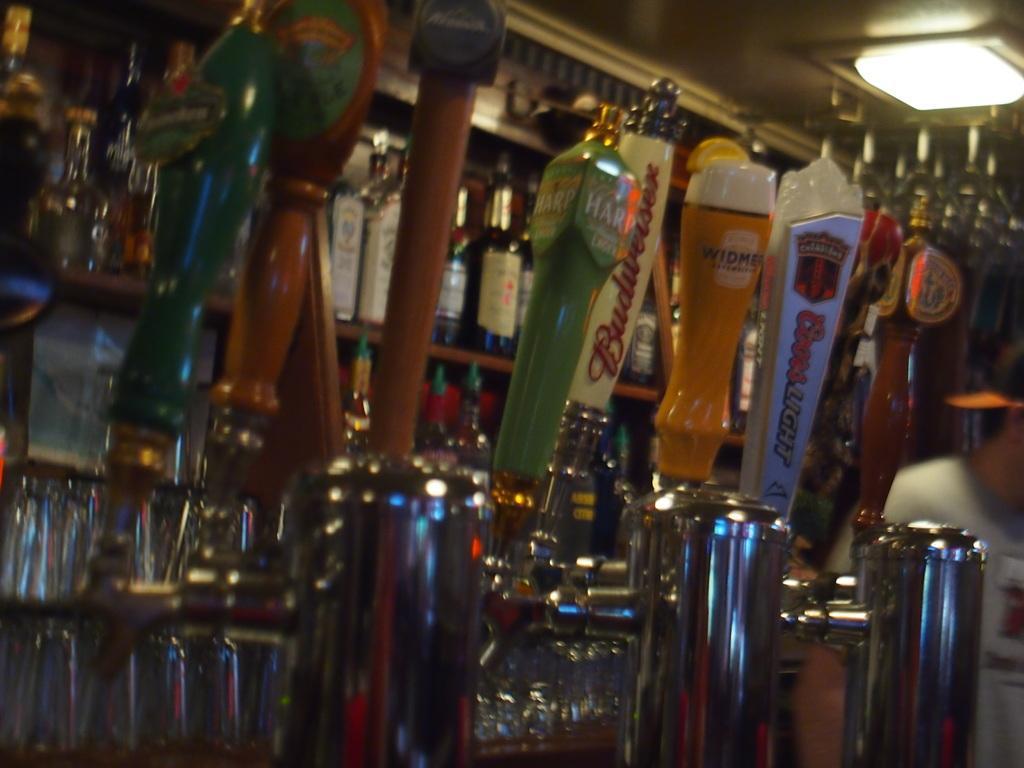Can you describe this image briefly? This rack is filled with bottles. On top there is a light. 